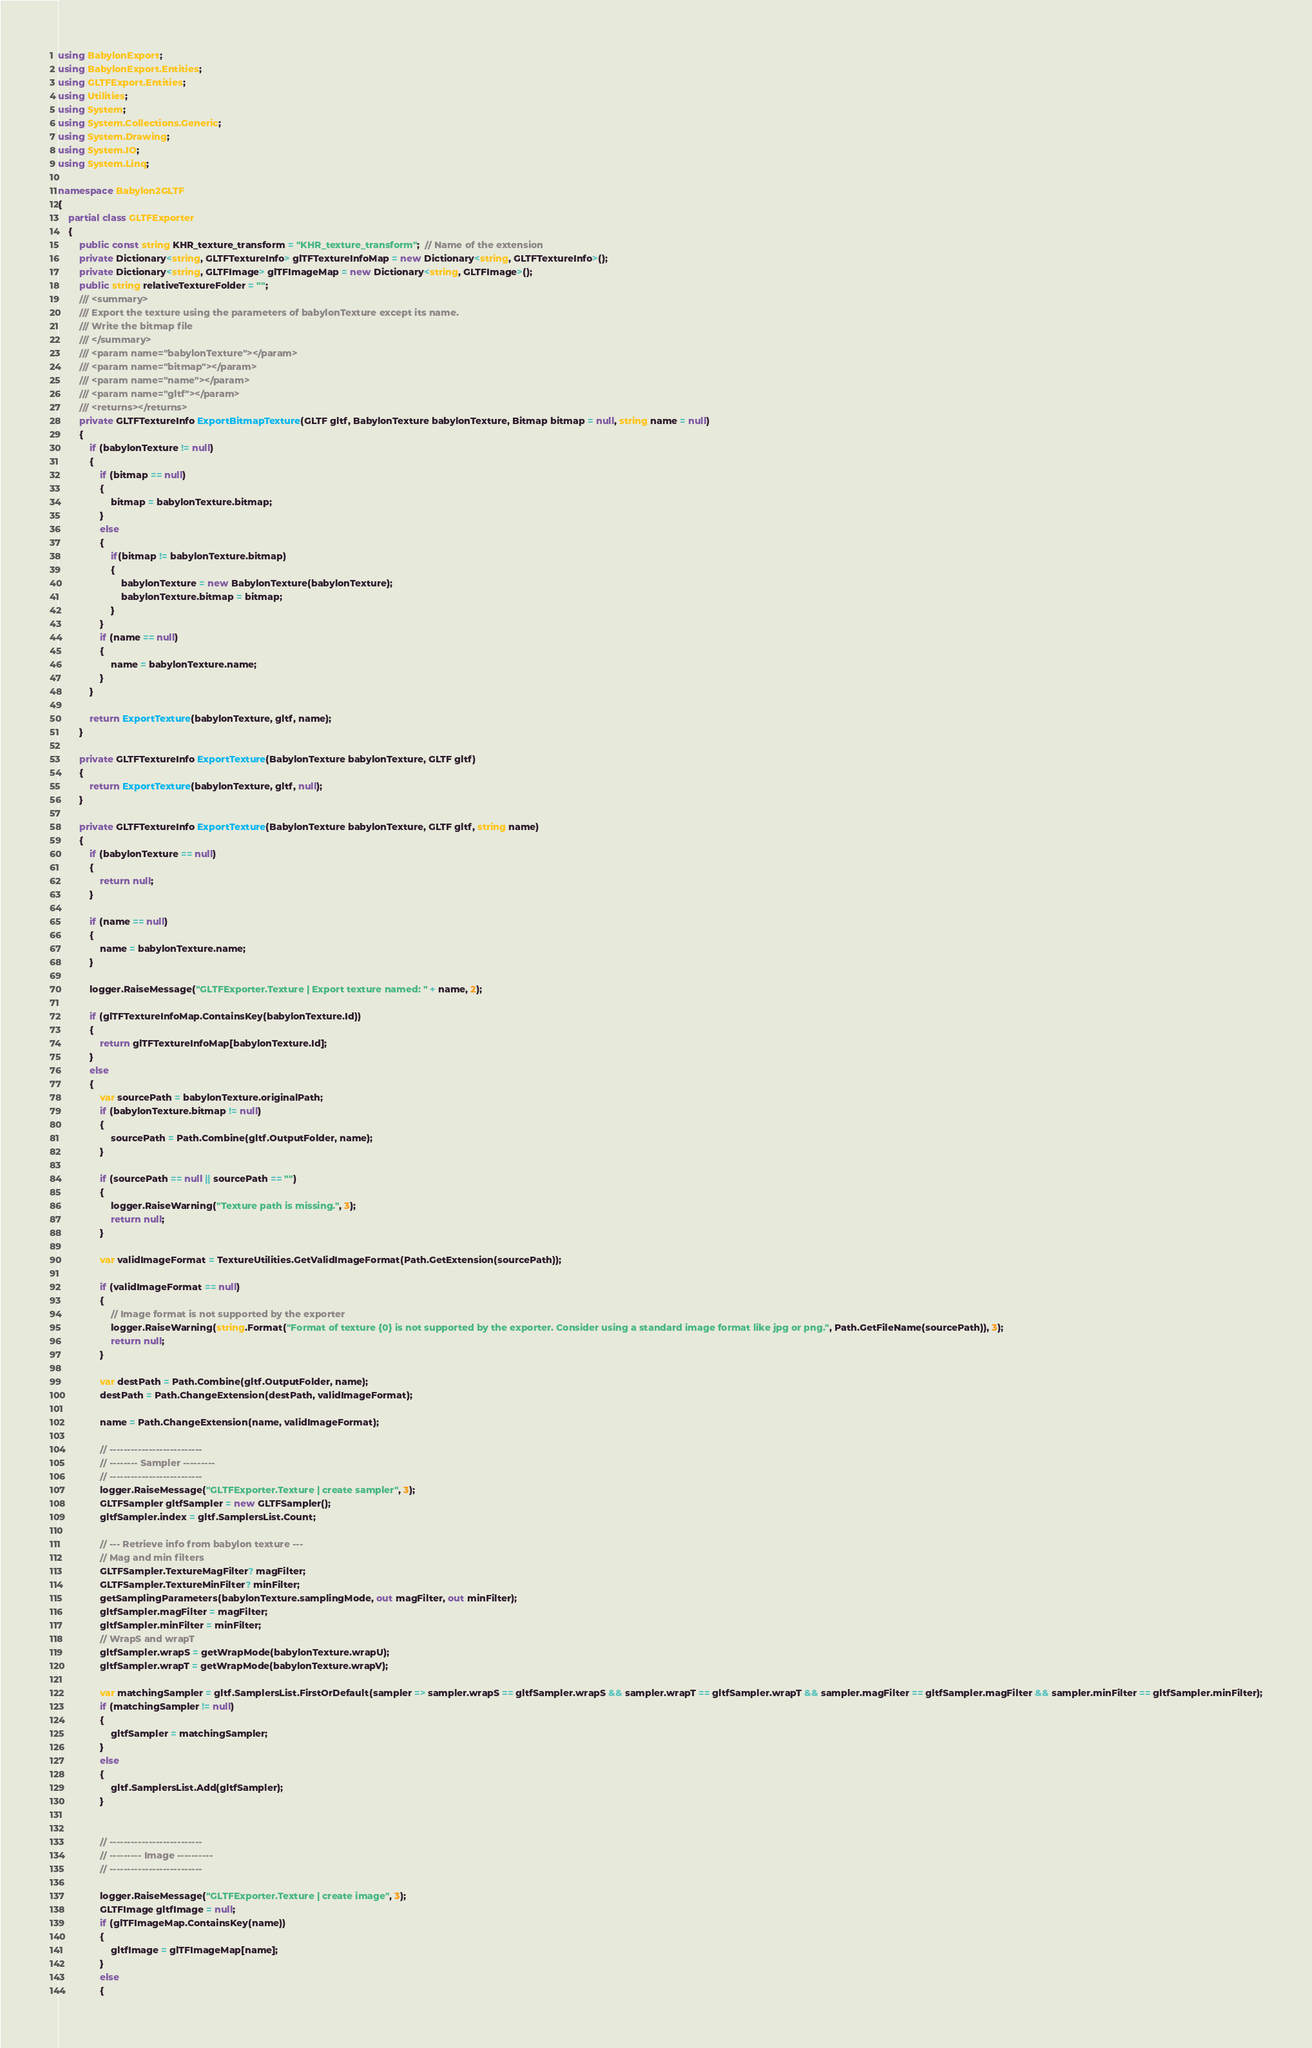Convert code to text. <code><loc_0><loc_0><loc_500><loc_500><_C#_>using BabylonExport;
using BabylonExport.Entities;
using GLTFExport.Entities;
using Utilities;
using System;
using System.Collections.Generic;
using System.Drawing;
using System.IO;
using System.Linq;

namespace Babylon2GLTF
{
    partial class GLTFExporter
    {
        public const string KHR_texture_transform = "KHR_texture_transform";  // Name of the extension
        private Dictionary<string, GLTFTextureInfo> glTFTextureInfoMap = new Dictionary<string, GLTFTextureInfo>();
        private Dictionary<string, GLTFImage> glTFImageMap = new Dictionary<string, GLTFImage>();
        public string relativeTextureFolder = "";
        /// <summary>
        /// Export the texture using the parameters of babylonTexture except its name.
        /// Write the bitmap file
        /// </summary>
        /// <param name="babylonTexture"></param>
        /// <param name="bitmap"></param>
        /// <param name="name"></param>
        /// <param name="gltf"></param>
        /// <returns></returns>
        private GLTFTextureInfo ExportBitmapTexture(GLTF gltf, BabylonTexture babylonTexture, Bitmap bitmap = null, string name = null)
        {
            if (babylonTexture != null)
            {
                if (bitmap == null)
                {
                    bitmap = babylonTexture.bitmap;
                }
                else
                {
                    if(bitmap != babylonTexture.bitmap)
                    {
                        babylonTexture = new BabylonTexture(babylonTexture);
                        babylonTexture.bitmap = bitmap;
                    }
                }
                if (name == null)
                {
                    name = babylonTexture.name;
                }
            }

            return ExportTexture(babylonTexture, gltf, name);
        }

        private GLTFTextureInfo ExportTexture(BabylonTexture babylonTexture, GLTF gltf)
        {
            return ExportTexture(babylonTexture, gltf, null);
        }

        private GLTFTextureInfo ExportTexture(BabylonTexture babylonTexture, GLTF gltf, string name)
        {
            if (babylonTexture == null)
            {
                return null;
            }

            if (name == null)
            {
                name = babylonTexture.name;
            }

            logger.RaiseMessage("GLTFExporter.Texture | Export texture named: " + name, 2);

            if (glTFTextureInfoMap.ContainsKey(babylonTexture.Id))
            {
                return glTFTextureInfoMap[babylonTexture.Id];
            }
            else
            {
                var sourcePath = babylonTexture.originalPath;
                if (babylonTexture.bitmap != null)
                {
                    sourcePath = Path.Combine(gltf.OutputFolder, name);
                }
                
                if (sourcePath == null || sourcePath == "")
                {
                    logger.RaiseWarning("Texture path is missing.", 3);
                    return null;
                }

                var validImageFormat = TextureUtilities.GetValidImageFormat(Path.GetExtension(sourcePath));

                if (validImageFormat == null)
                {
                    // Image format is not supported by the exporter
                    logger.RaiseWarning(string.Format("Format of texture {0} is not supported by the exporter. Consider using a standard image format like jpg or png.", Path.GetFileName(sourcePath)), 3);
                    return null;
                }

                var destPath = Path.Combine(gltf.OutputFolder, name);
                destPath = Path.ChangeExtension(destPath, validImageFormat);

                name = Path.ChangeExtension(name, validImageFormat);

                // --------------------------
                // -------- Sampler ---------
                // --------------------------
                logger.RaiseMessage("GLTFExporter.Texture | create sampler", 3);
                GLTFSampler gltfSampler = new GLTFSampler();
                gltfSampler.index = gltf.SamplersList.Count;
                
                // --- Retrieve info from babylon texture ---
                // Mag and min filters
                GLTFSampler.TextureMagFilter? magFilter;
                GLTFSampler.TextureMinFilter? minFilter;
                getSamplingParameters(babylonTexture.samplingMode, out magFilter, out minFilter);
                gltfSampler.magFilter = magFilter;
                gltfSampler.minFilter = minFilter;
                // WrapS and wrapT
                gltfSampler.wrapS = getWrapMode(babylonTexture.wrapU);
                gltfSampler.wrapT = getWrapMode(babylonTexture.wrapV);

                var matchingSampler = gltf.SamplersList.FirstOrDefault(sampler => sampler.wrapS == gltfSampler.wrapS && sampler.wrapT == gltfSampler.wrapT && sampler.magFilter == gltfSampler.magFilter && sampler.minFilter == gltfSampler.minFilter);
                if (matchingSampler != null)
                {
                    gltfSampler = matchingSampler;
                }
                else
                {
                    gltf.SamplersList.Add(gltfSampler);
                }


                // --------------------------
                // --------- Image ----------
                // --------------------------

                logger.RaiseMessage("GLTFExporter.Texture | create image", 3);
                GLTFImage gltfImage = null;
                if (glTFImageMap.ContainsKey(name))
                {
                    gltfImage = glTFImageMap[name];
                }
                else
                {</code> 